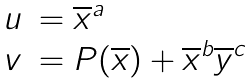<formula> <loc_0><loc_0><loc_500><loc_500>\begin{array} { l l } u & = \overline { x } ^ { a } \\ v & = P ( \overline { x } ) + \overline { x } ^ { b } \overline { y } ^ { c } \end{array}</formula> 